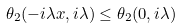Convert formula to latex. <formula><loc_0><loc_0><loc_500><loc_500>\theta _ { 2 } ( - i \lambda x , i \lambda ) \leq \theta _ { 2 } ( 0 , i \lambda )</formula> 